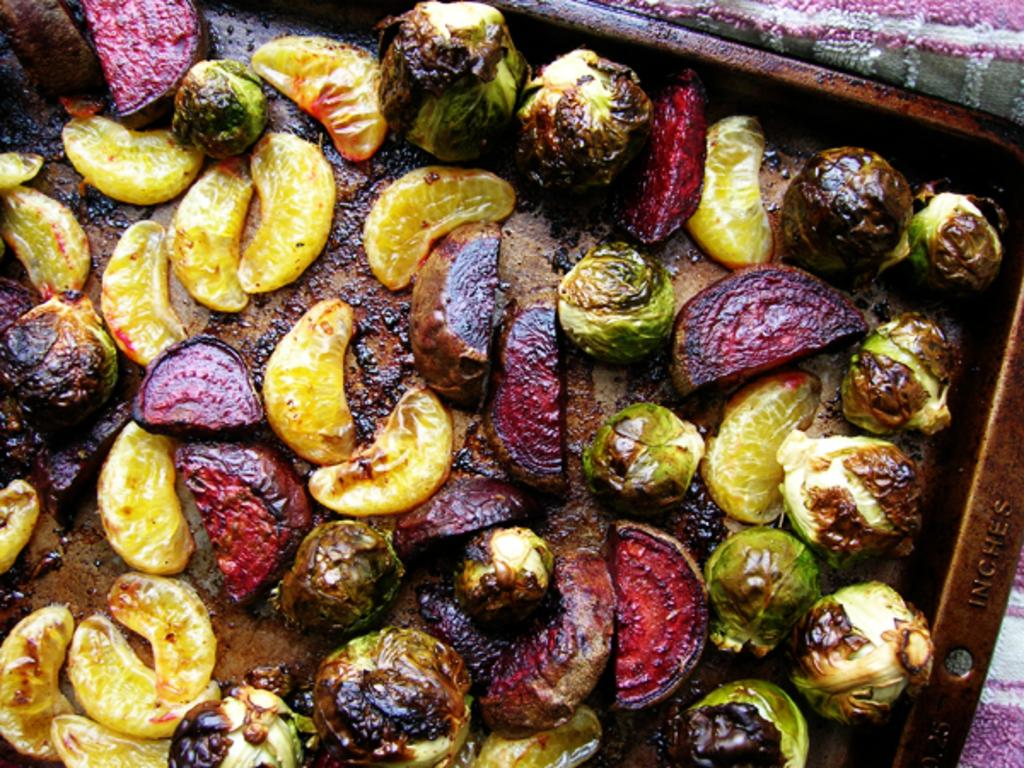What types of food items are on the trays in the foreground of the image? There are vegetables and fruits on the trays in the foreground of the image. Can you describe the arrangement of the food items on the trays? The vegetables and fruits are arranged on separate trays in the foreground of the image. What can be seen in the background of the image? There is a cloth visible in the background of the image. What type of yarn is being used by the manager in the image? There is no manager or yarn present in the image. What shocking event occurs in the image? There is no shocking event depicted in the image. 